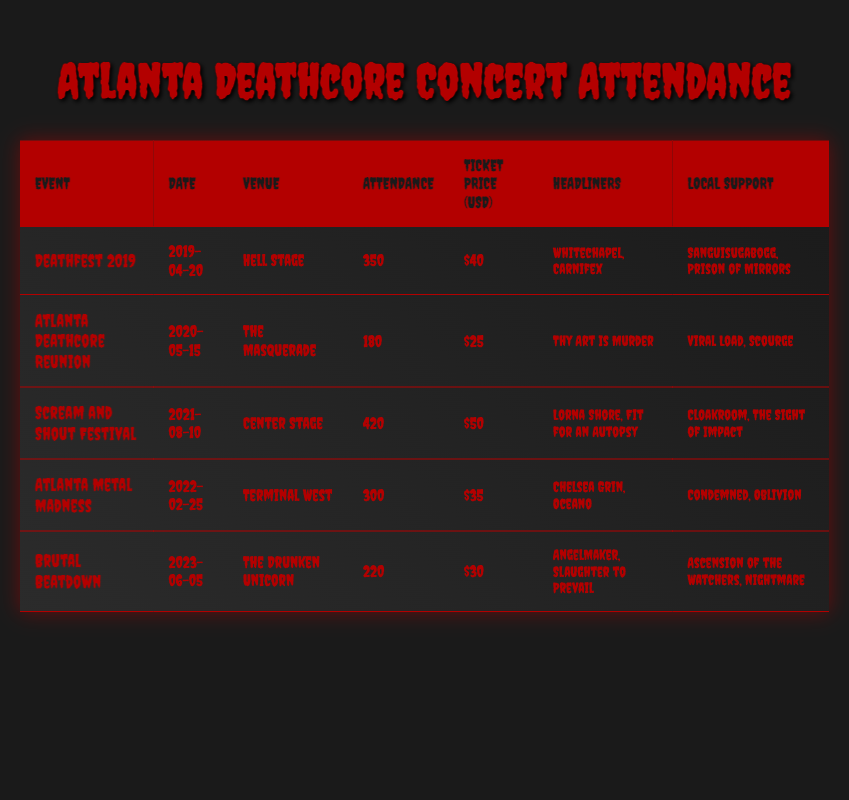What was the attendance for the Scream and Shout Festival? The attendance for the Scream and Shout Festival, which took place on August 10, 2021, is listed as 420 in the table.
Answer: 420 Which event had the highest ticket price? To find the highest ticket price, we compare the ticket prices for all events: $40 (Deathfest 2019), $25 (Atlanta Deathcore Reunion), $50 (Scream and Shout Festival), $35 (Atlanta Metal Madness), and $30 (Brutal Beatdown). The highest price is $50 for the Scream and Shout Festival.
Answer: $50 Was there more than one headliner for the Atlanta Metal Madness? The Atlanta Metal Madness had two headliners listed: Chelsea Grin and Oceano. Therefore, the answer is yes.
Answer: Yes What is the average attendance of the concerts held in 2022 and 2023? For 2022, the attendance for Atlanta Metal Madness was 300. For 2023, the attendance for Brutal Beatdown was 220. The average attendance is calculated by summing these attendances (300 + 220 = 520) and dividing by the number of events (2), which gives 520/2 = 260.
Answer: 260 How many local support bands played at the Scream and Shout Festival? The Scream and Shout Festival featured two local support bands: Cloakroom and The Sight of Impact. Thus, the count is two.
Answer: 2 Which concert had the lowest attendance, and what was it? By reviewing the attendance column for all events, we see the following attendances: 350, 180, 420, 300, and 220. The lowest attendance is 180, which corresponds to the Atlanta Deathcore Reunion.
Answer: Atlanta Deathcore Reunion, 180 What was the total attendance across all events listed? The total attendance is the sum of attendances from all events: 350 (Deathfest 2019) + 180 (Atlanta Deathcore Reunion) + 420 (Scream and Shout Festival) + 300 (Atlanta Metal Madness) + 220 (Brutal Beatdown) = 1470.
Answer: 1470 Did the Hell Stage host more concerts than The Masquerade? There is only one concert listed for the Hell Stage (Deathfest 2019) and one concert listed for The Masquerade (Atlanta Deathcore Reunion). Since both have the same count, the answer is no.
Answer: No 